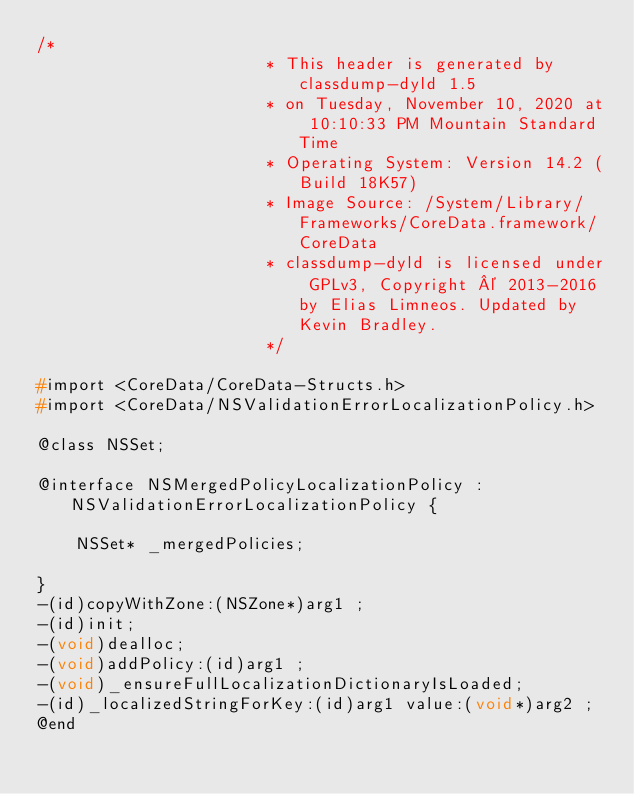<code> <loc_0><loc_0><loc_500><loc_500><_C_>/*
                       * This header is generated by classdump-dyld 1.5
                       * on Tuesday, November 10, 2020 at 10:10:33 PM Mountain Standard Time
                       * Operating System: Version 14.2 (Build 18K57)
                       * Image Source: /System/Library/Frameworks/CoreData.framework/CoreData
                       * classdump-dyld is licensed under GPLv3, Copyright © 2013-2016 by Elias Limneos. Updated by Kevin Bradley.
                       */

#import <CoreData/CoreData-Structs.h>
#import <CoreData/NSValidationErrorLocalizationPolicy.h>

@class NSSet;

@interface NSMergedPolicyLocalizationPolicy : NSValidationErrorLocalizationPolicy {

	NSSet* _mergedPolicies;

}
-(id)copyWithZone:(NSZone*)arg1 ;
-(id)init;
-(void)dealloc;
-(void)addPolicy:(id)arg1 ;
-(void)_ensureFullLocalizationDictionaryIsLoaded;
-(id)_localizedStringForKey:(id)arg1 value:(void*)arg2 ;
@end

</code> 